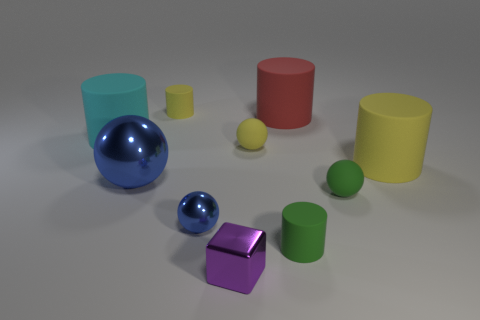Subtract 1 balls. How many balls are left? 3 Subtract all green cylinders. How many cylinders are left? 4 Subtract all cyan rubber cylinders. How many cylinders are left? 4 Subtract all gray cylinders. Subtract all red cubes. How many cylinders are left? 5 Subtract all cubes. How many objects are left? 9 Subtract 1 red cylinders. How many objects are left? 9 Subtract all tiny green matte objects. Subtract all small blue balls. How many objects are left? 7 Add 3 large yellow things. How many large yellow things are left? 4 Add 6 big purple shiny blocks. How many big purple shiny blocks exist? 6 